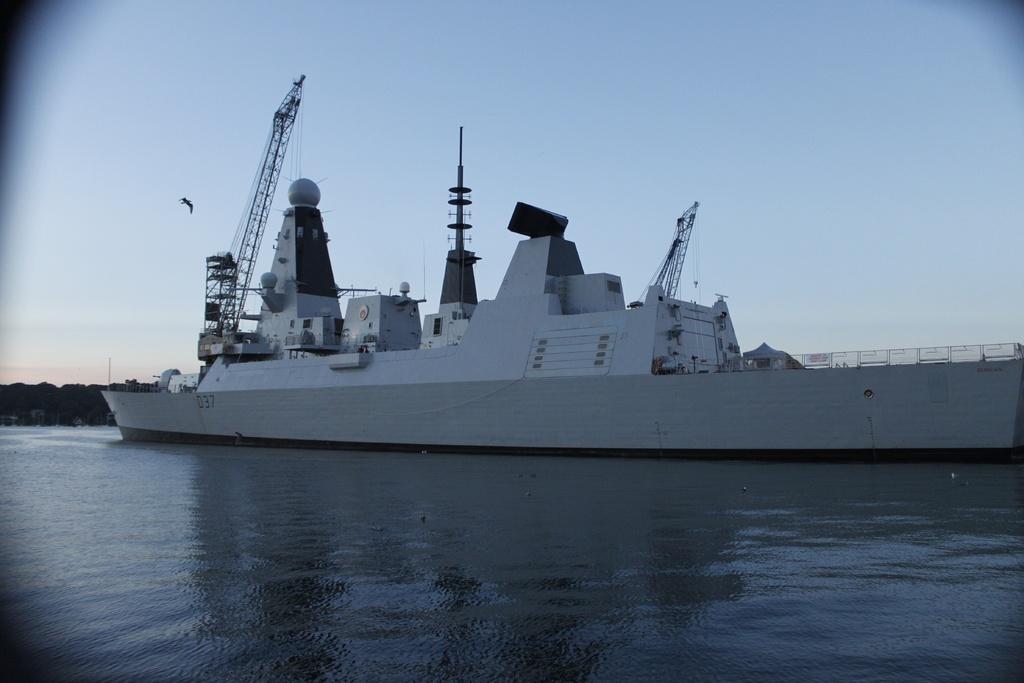Could you give a brief overview of what you see in this image? In the center of the image there is a ship on the water. In the background there are buildings, trees, bird and sky. At the bottom there is a water. 